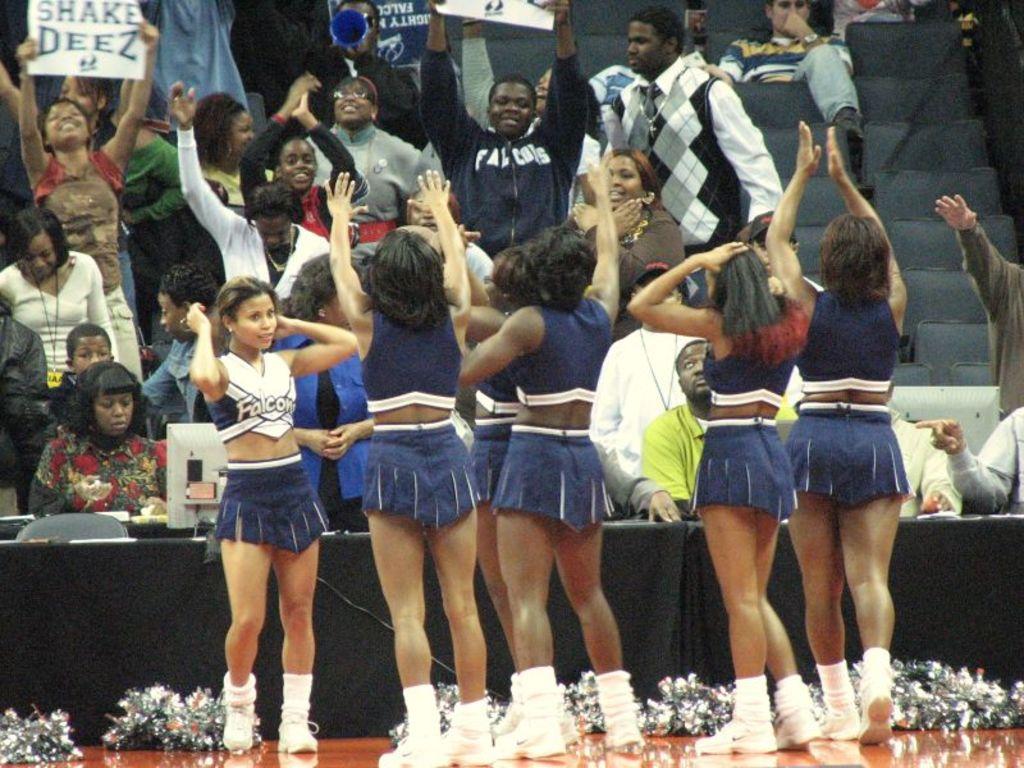What team do the cheerleaders play cheer for?
Make the answer very short. Falcons. What are they supposed to shake?
Provide a succinct answer. Deez. 